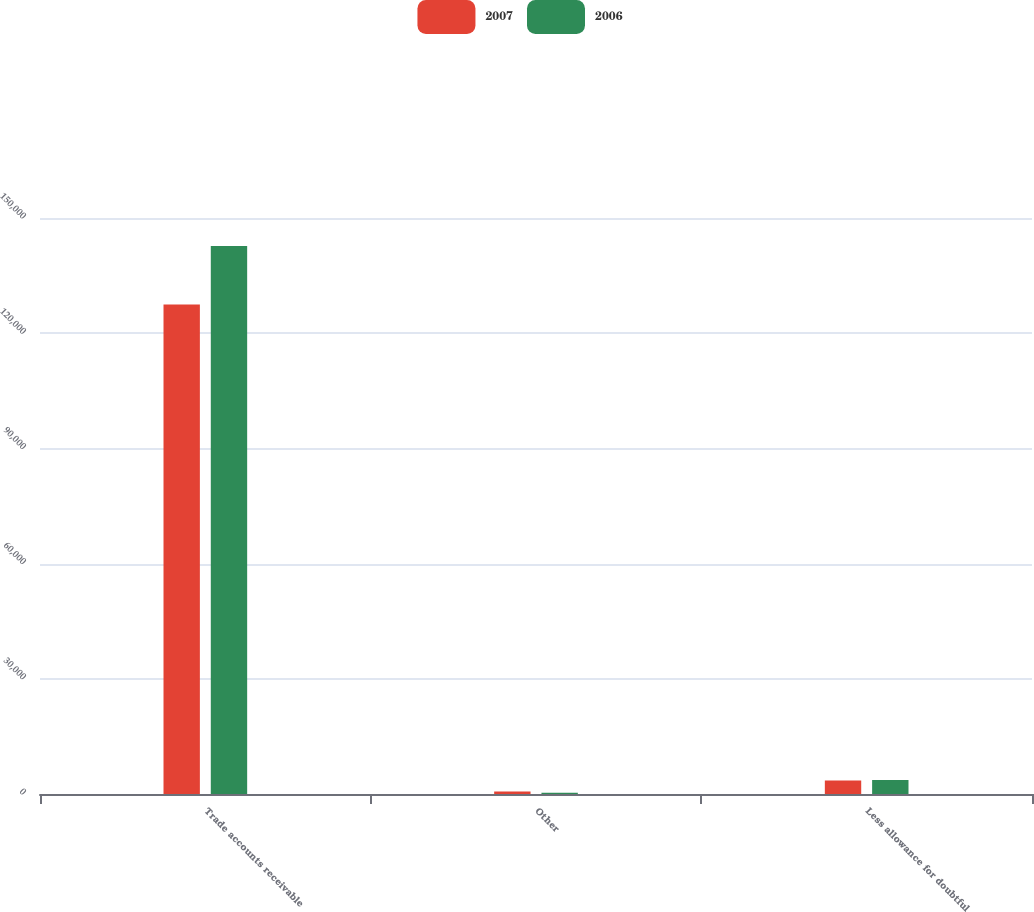Convert chart. <chart><loc_0><loc_0><loc_500><loc_500><stacked_bar_chart><ecel><fcel>Trade accounts receivable<fcel>Other<fcel>Less allowance for doubtful<nl><fcel>2007<fcel>127467<fcel>636<fcel>3544<nl><fcel>2006<fcel>142703<fcel>320<fcel>3662<nl></chart> 